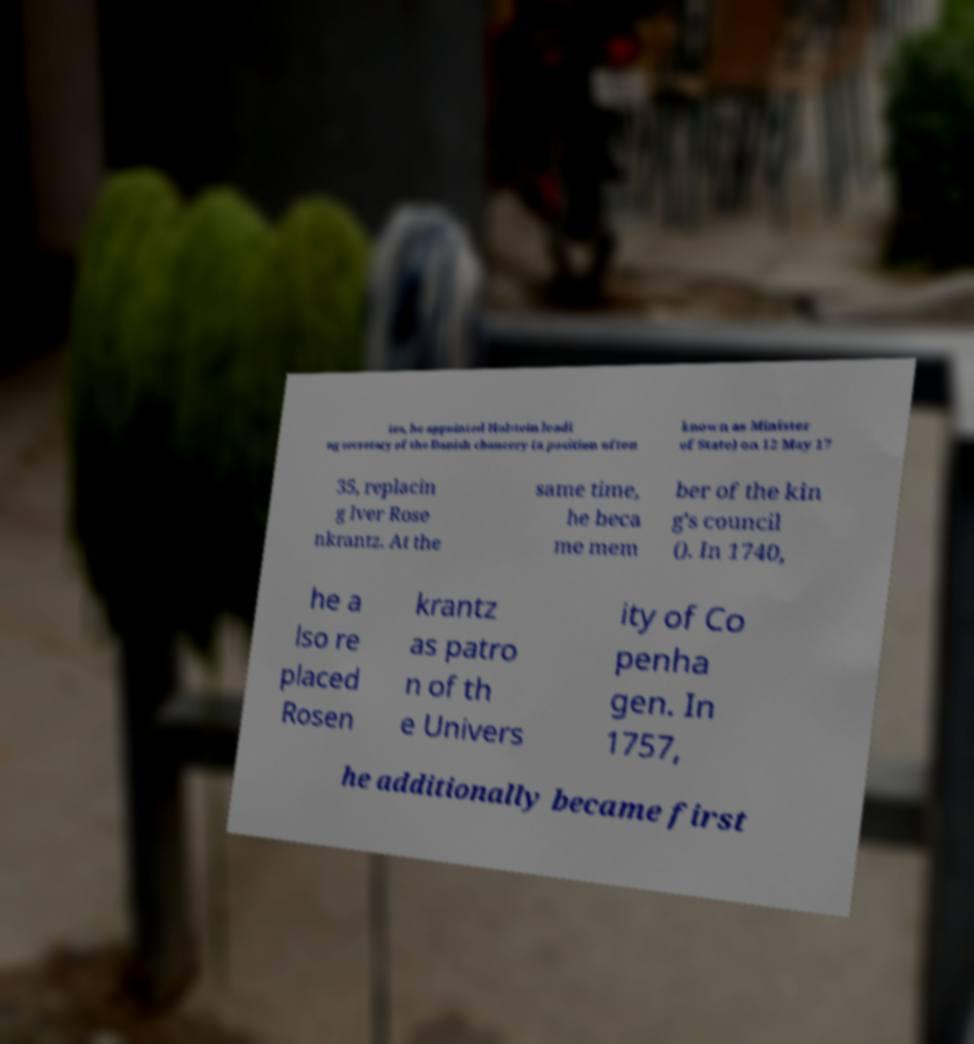I need the written content from this picture converted into text. Can you do that? ies, he appointed Holstein leadi ng secretary of the Danish chancery (a position often known as Minister of State) on 12 May 17 35, replacin g Iver Rose nkrantz. At the same time, he beca me mem ber of the kin g's council (). In 1740, he a lso re placed Rosen krantz as patro n of th e Univers ity of Co penha gen. In 1757, he additionally became first 